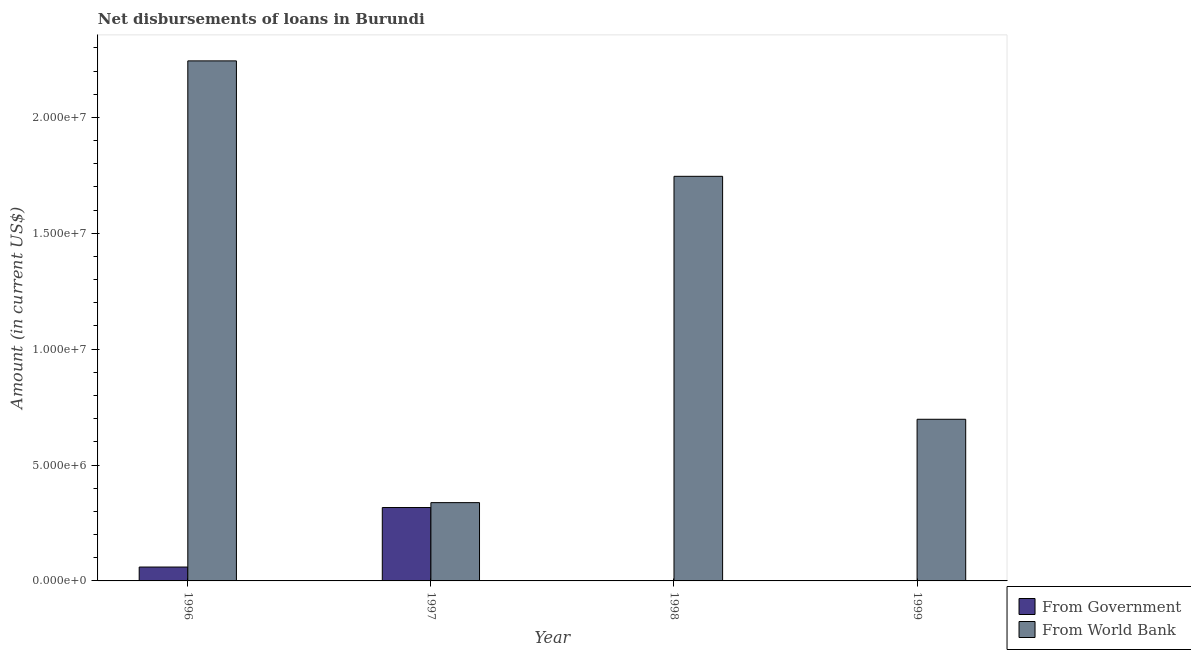Are the number of bars per tick equal to the number of legend labels?
Offer a terse response. No. How many bars are there on the 1st tick from the left?
Give a very brief answer. 2. What is the label of the 3rd group of bars from the left?
Keep it short and to the point. 1998. What is the net disbursements of loan from government in 1998?
Offer a terse response. 0. Across all years, what is the maximum net disbursements of loan from world bank?
Make the answer very short. 2.24e+07. Across all years, what is the minimum net disbursements of loan from world bank?
Your answer should be very brief. 3.38e+06. In which year was the net disbursements of loan from world bank maximum?
Offer a terse response. 1996. What is the total net disbursements of loan from government in the graph?
Make the answer very short. 3.77e+06. What is the difference between the net disbursements of loan from world bank in 1996 and that in 1999?
Offer a terse response. 1.55e+07. What is the difference between the net disbursements of loan from world bank in 1997 and the net disbursements of loan from government in 1998?
Offer a terse response. -1.41e+07. What is the average net disbursements of loan from government per year?
Offer a terse response. 9.42e+05. What is the ratio of the net disbursements of loan from world bank in 1996 to that in 1999?
Keep it short and to the point. 3.22. Is the net disbursements of loan from world bank in 1998 less than that in 1999?
Your answer should be compact. No. Is the difference between the net disbursements of loan from world bank in 1996 and 1998 greater than the difference between the net disbursements of loan from government in 1996 and 1998?
Ensure brevity in your answer.  No. What is the difference between the highest and the second highest net disbursements of loan from world bank?
Your answer should be very brief. 4.98e+06. What is the difference between the highest and the lowest net disbursements of loan from government?
Ensure brevity in your answer.  3.17e+06. Is the sum of the net disbursements of loan from government in 1996 and 1997 greater than the maximum net disbursements of loan from world bank across all years?
Your response must be concise. Yes. How many bars are there?
Provide a short and direct response. 6. How many years are there in the graph?
Offer a terse response. 4. What is the difference between two consecutive major ticks on the Y-axis?
Give a very brief answer. 5.00e+06. Are the values on the major ticks of Y-axis written in scientific E-notation?
Provide a succinct answer. Yes. What is the title of the graph?
Give a very brief answer. Net disbursements of loans in Burundi. Does "Net savings(excluding particulate emission damage)" appear as one of the legend labels in the graph?
Provide a short and direct response. No. What is the label or title of the X-axis?
Provide a succinct answer. Year. What is the Amount (in current US$) of From Government in 1996?
Your answer should be very brief. 5.99e+05. What is the Amount (in current US$) of From World Bank in 1996?
Keep it short and to the point. 2.24e+07. What is the Amount (in current US$) of From Government in 1997?
Make the answer very short. 3.17e+06. What is the Amount (in current US$) in From World Bank in 1997?
Offer a terse response. 3.38e+06. What is the Amount (in current US$) of From Government in 1998?
Give a very brief answer. 0. What is the Amount (in current US$) in From World Bank in 1998?
Your answer should be very brief. 1.75e+07. What is the Amount (in current US$) in From World Bank in 1999?
Offer a very short reply. 6.98e+06. Across all years, what is the maximum Amount (in current US$) in From Government?
Your answer should be compact. 3.17e+06. Across all years, what is the maximum Amount (in current US$) in From World Bank?
Your response must be concise. 2.24e+07. Across all years, what is the minimum Amount (in current US$) in From World Bank?
Give a very brief answer. 3.38e+06. What is the total Amount (in current US$) in From Government in the graph?
Your answer should be compact. 3.77e+06. What is the total Amount (in current US$) in From World Bank in the graph?
Provide a short and direct response. 5.02e+07. What is the difference between the Amount (in current US$) in From Government in 1996 and that in 1997?
Offer a terse response. -2.57e+06. What is the difference between the Amount (in current US$) in From World Bank in 1996 and that in 1997?
Ensure brevity in your answer.  1.91e+07. What is the difference between the Amount (in current US$) in From World Bank in 1996 and that in 1998?
Give a very brief answer. 4.98e+06. What is the difference between the Amount (in current US$) of From World Bank in 1996 and that in 1999?
Make the answer very short. 1.55e+07. What is the difference between the Amount (in current US$) of From World Bank in 1997 and that in 1998?
Keep it short and to the point. -1.41e+07. What is the difference between the Amount (in current US$) in From World Bank in 1997 and that in 1999?
Provide a short and direct response. -3.60e+06. What is the difference between the Amount (in current US$) of From World Bank in 1998 and that in 1999?
Ensure brevity in your answer.  1.05e+07. What is the difference between the Amount (in current US$) in From Government in 1996 and the Amount (in current US$) in From World Bank in 1997?
Your response must be concise. -2.78e+06. What is the difference between the Amount (in current US$) of From Government in 1996 and the Amount (in current US$) of From World Bank in 1998?
Offer a terse response. -1.69e+07. What is the difference between the Amount (in current US$) in From Government in 1996 and the Amount (in current US$) in From World Bank in 1999?
Ensure brevity in your answer.  -6.38e+06. What is the difference between the Amount (in current US$) of From Government in 1997 and the Amount (in current US$) of From World Bank in 1998?
Offer a terse response. -1.43e+07. What is the difference between the Amount (in current US$) of From Government in 1997 and the Amount (in current US$) of From World Bank in 1999?
Offer a very short reply. -3.81e+06. What is the average Amount (in current US$) of From Government per year?
Your answer should be very brief. 9.42e+05. What is the average Amount (in current US$) of From World Bank per year?
Your response must be concise. 1.26e+07. In the year 1996, what is the difference between the Amount (in current US$) of From Government and Amount (in current US$) of From World Bank?
Offer a terse response. -2.18e+07. In the year 1997, what is the difference between the Amount (in current US$) in From Government and Amount (in current US$) in From World Bank?
Offer a terse response. -2.11e+05. What is the ratio of the Amount (in current US$) in From Government in 1996 to that in 1997?
Provide a succinct answer. 0.19. What is the ratio of the Amount (in current US$) of From World Bank in 1996 to that in 1997?
Offer a terse response. 6.64. What is the ratio of the Amount (in current US$) in From World Bank in 1996 to that in 1998?
Ensure brevity in your answer.  1.29. What is the ratio of the Amount (in current US$) of From World Bank in 1996 to that in 1999?
Provide a succinct answer. 3.22. What is the ratio of the Amount (in current US$) of From World Bank in 1997 to that in 1998?
Your answer should be compact. 0.19. What is the ratio of the Amount (in current US$) of From World Bank in 1997 to that in 1999?
Give a very brief answer. 0.48. What is the ratio of the Amount (in current US$) of From World Bank in 1998 to that in 1999?
Your answer should be very brief. 2.5. What is the difference between the highest and the second highest Amount (in current US$) in From World Bank?
Ensure brevity in your answer.  4.98e+06. What is the difference between the highest and the lowest Amount (in current US$) of From Government?
Keep it short and to the point. 3.17e+06. What is the difference between the highest and the lowest Amount (in current US$) in From World Bank?
Ensure brevity in your answer.  1.91e+07. 